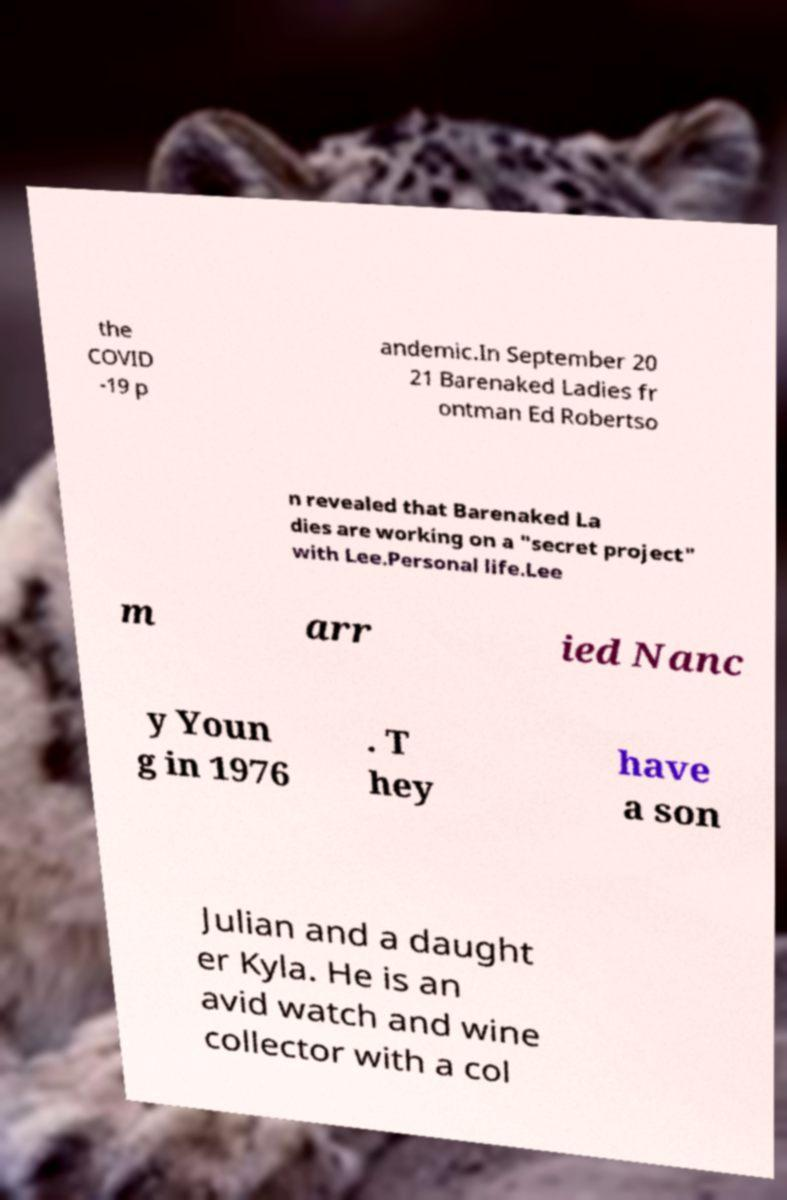Could you assist in decoding the text presented in this image and type it out clearly? the COVID -19 p andemic.In September 20 21 Barenaked Ladies fr ontman Ed Robertso n revealed that Barenaked La dies are working on a "secret project" with Lee.Personal life.Lee m arr ied Nanc y Youn g in 1976 . T hey have a son Julian and a daught er Kyla. He is an avid watch and wine collector with a col 